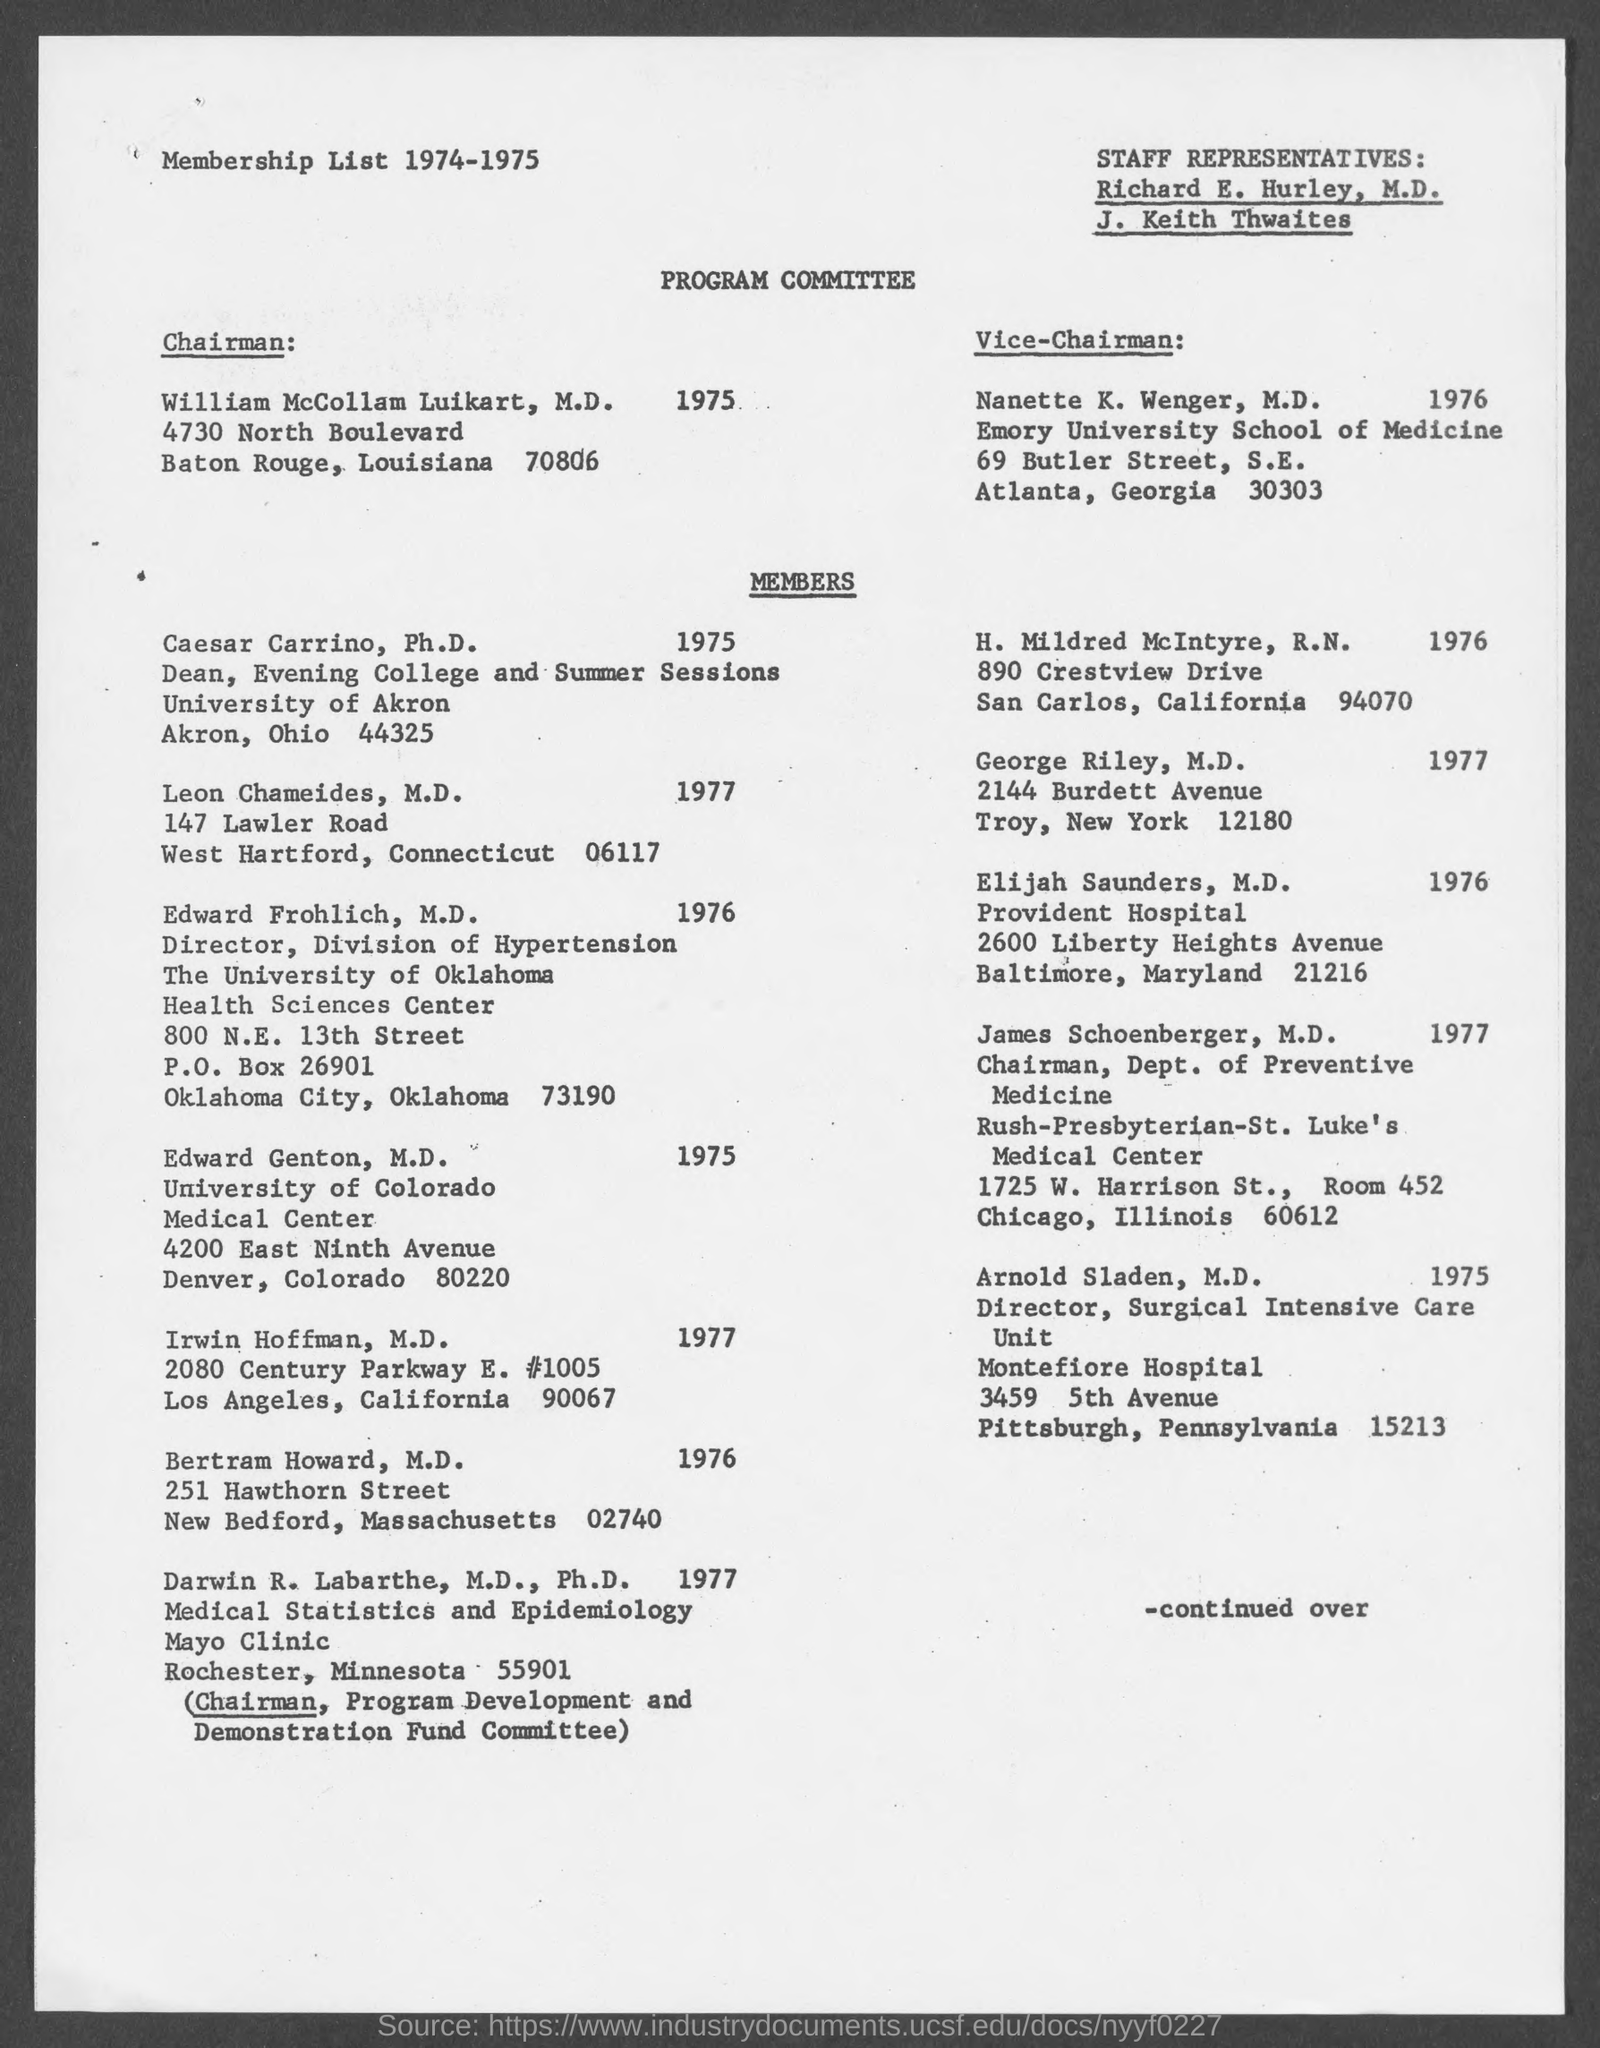Identify some key points in this picture. It is announced that Dr. William McCollam Luikart is the Chairman of the Program Committee. Nanette K. Wenger is the Vice-Chairman of the Program Committee. 